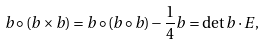Convert formula to latex. <formula><loc_0><loc_0><loc_500><loc_500>b \circ ( b \times b ) = b \circ ( b \circ b ) - \frac { 1 } { 4 } b = \det b \cdot E ,</formula> 